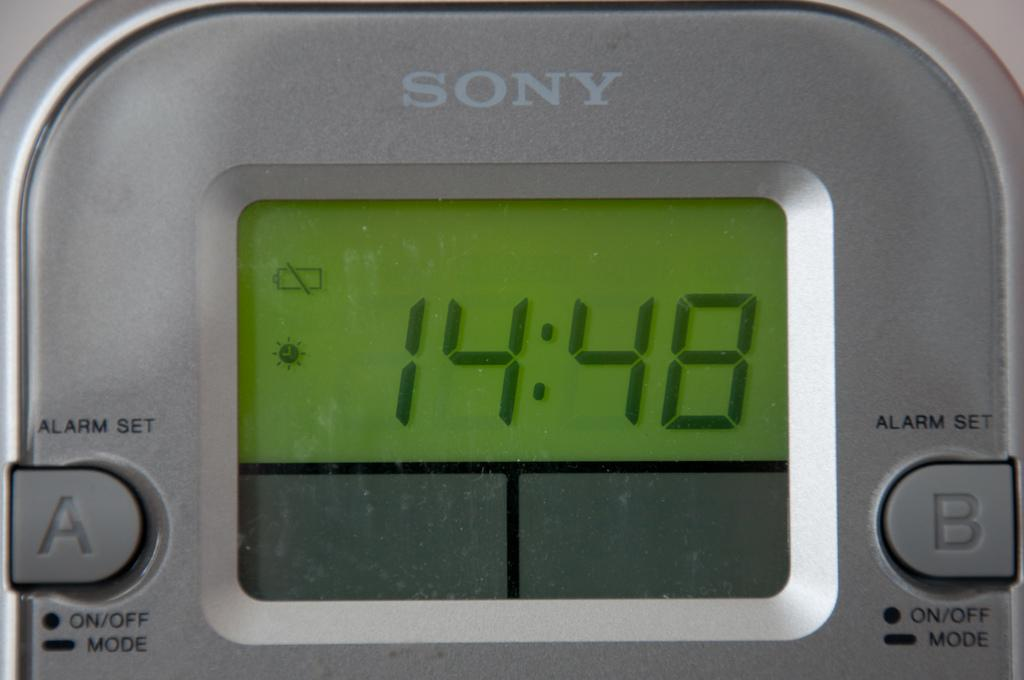<image>
Render a clear and concise summary of the photo. A Sony alarm clock that reads 14:48 on the screen. 